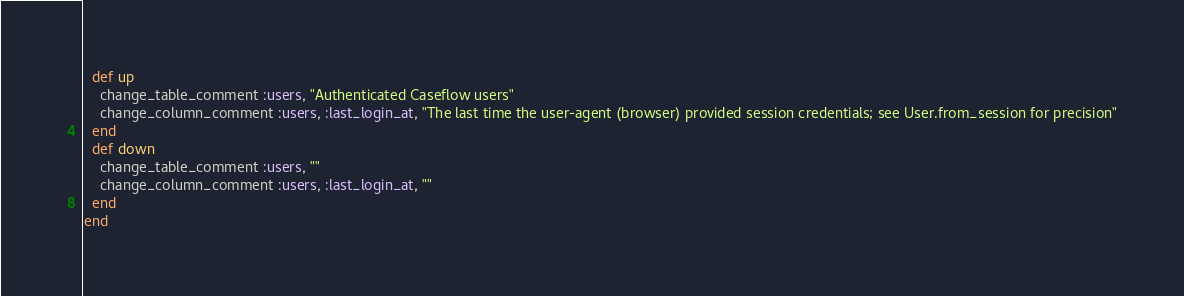Convert code to text. <code><loc_0><loc_0><loc_500><loc_500><_Ruby_>  def up
    change_table_comment :users, "Authenticated Caseflow users"
    change_column_comment :users, :last_login_at, "The last time the user-agent (browser) provided session credentials; see User.from_session for precision"
  end
  def down
    change_table_comment :users, ""
    change_column_comment :users, :last_login_at, ""
  end
end
</code> 